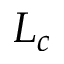Convert formula to latex. <formula><loc_0><loc_0><loc_500><loc_500>L _ { c }</formula> 